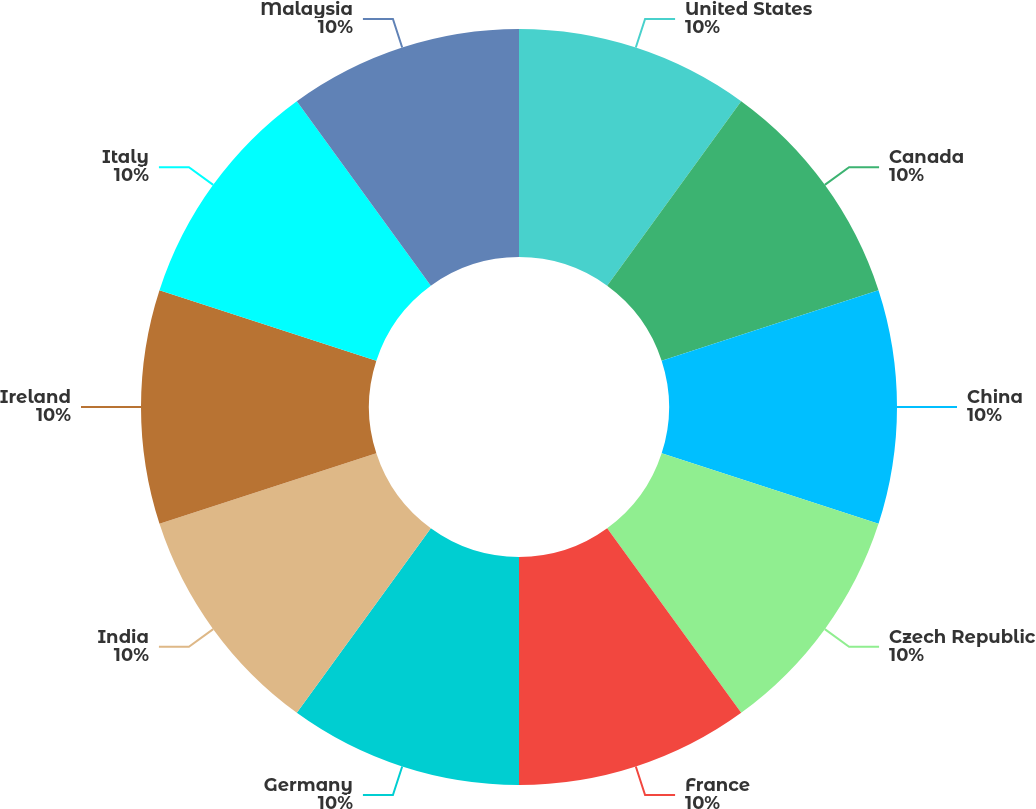Convert chart to OTSL. <chart><loc_0><loc_0><loc_500><loc_500><pie_chart><fcel>United States<fcel>Canada<fcel>China<fcel>Czech Republic<fcel>France<fcel>Germany<fcel>India<fcel>Ireland<fcel>Italy<fcel>Malaysia<nl><fcel>10.0%<fcel>10.0%<fcel>10.0%<fcel>10.0%<fcel>10.0%<fcel>10.0%<fcel>10.0%<fcel>10.0%<fcel>10.0%<fcel>10.0%<nl></chart> 